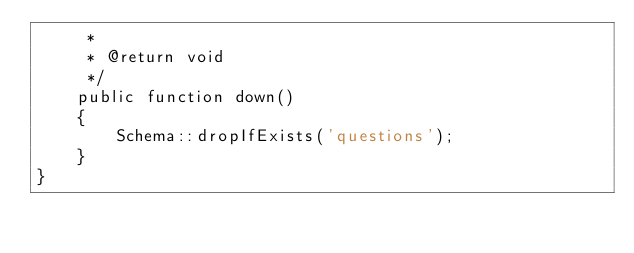<code> <loc_0><loc_0><loc_500><loc_500><_PHP_>     *
     * @return void
     */
    public function down()
    {
        Schema::dropIfExists('questions');
    }
}
</code> 